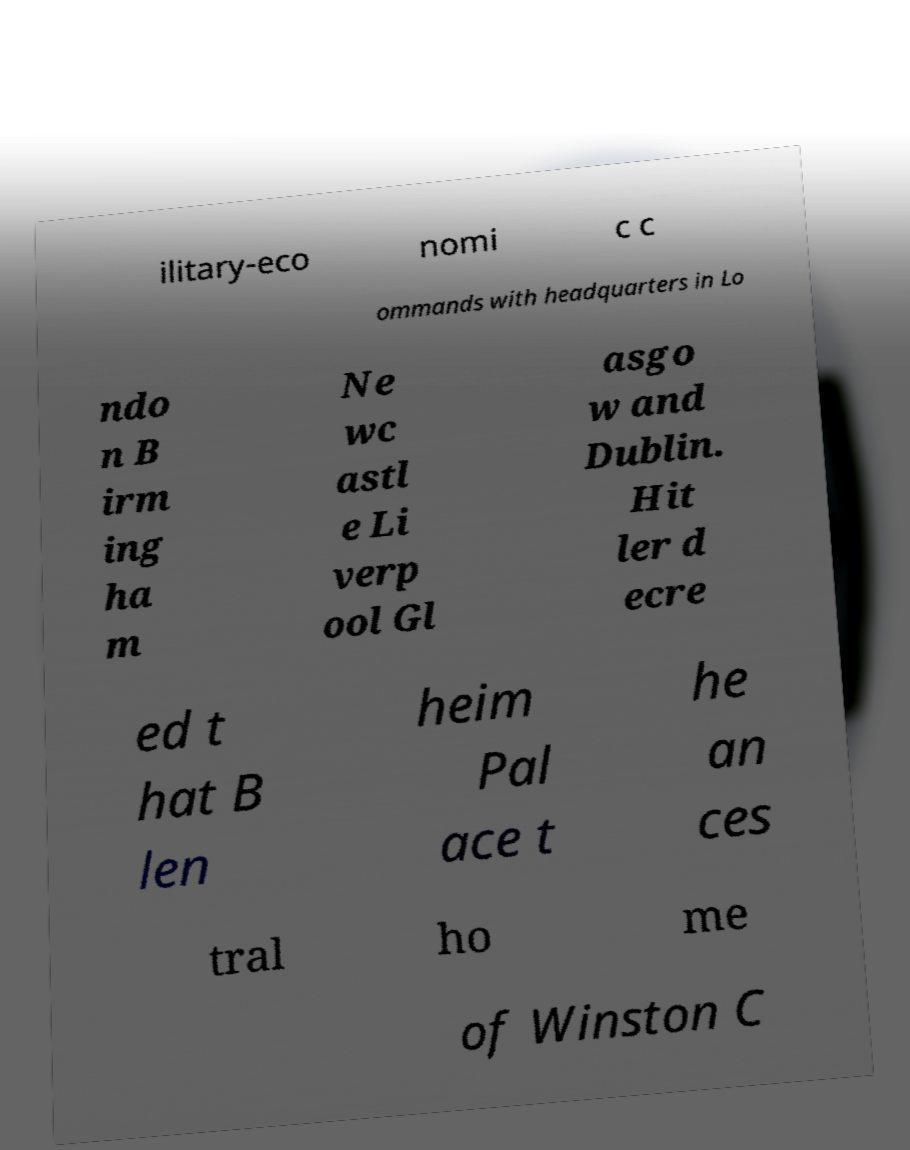Please read and relay the text visible in this image. What does it say? ilitary-eco nomi c c ommands with headquarters in Lo ndo n B irm ing ha m Ne wc astl e Li verp ool Gl asgo w and Dublin. Hit ler d ecre ed t hat B len heim Pal ace t he an ces tral ho me of Winston C 